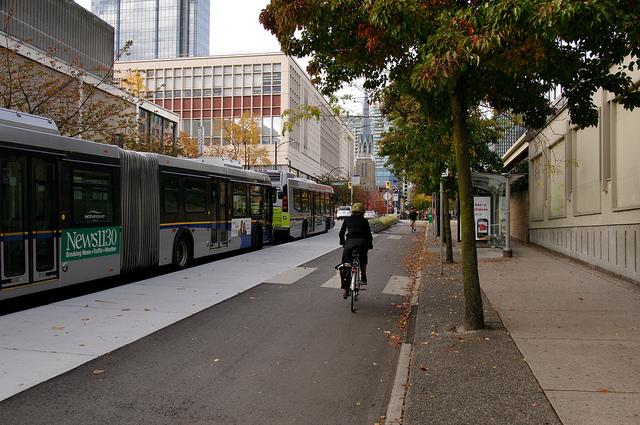What radio show is advertised on the bus?
Quick response, please. News1130. Does the bicycle have a rear rack?
Concise answer only. Yes. How many busses can be seen?
Give a very brief answer. 2. Is the road wet?
Keep it brief. No. What season is this?
Give a very brief answer. Fall. 